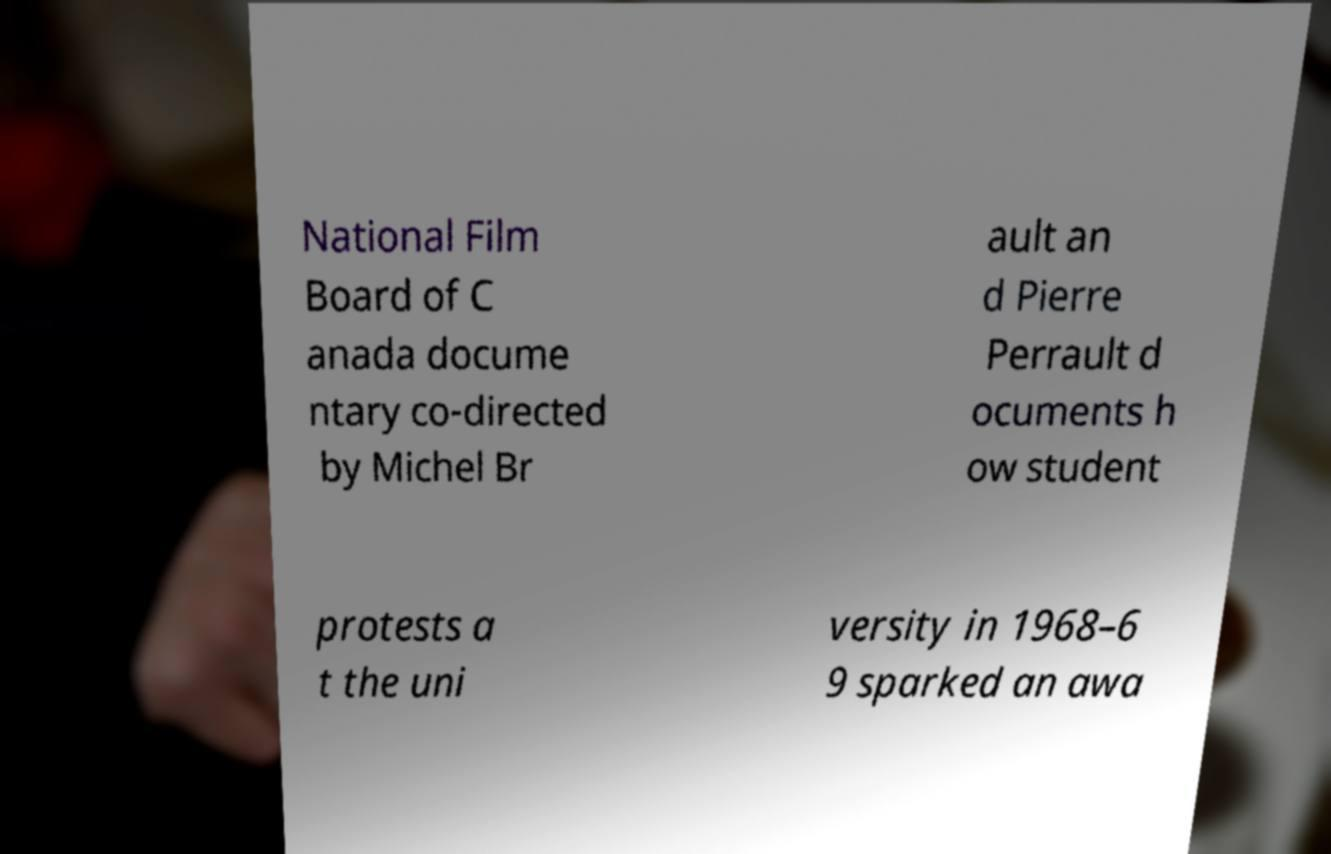For documentation purposes, I need the text within this image transcribed. Could you provide that? National Film Board of C anada docume ntary co-directed by Michel Br ault an d Pierre Perrault d ocuments h ow student protests a t the uni versity in 1968–6 9 sparked an awa 